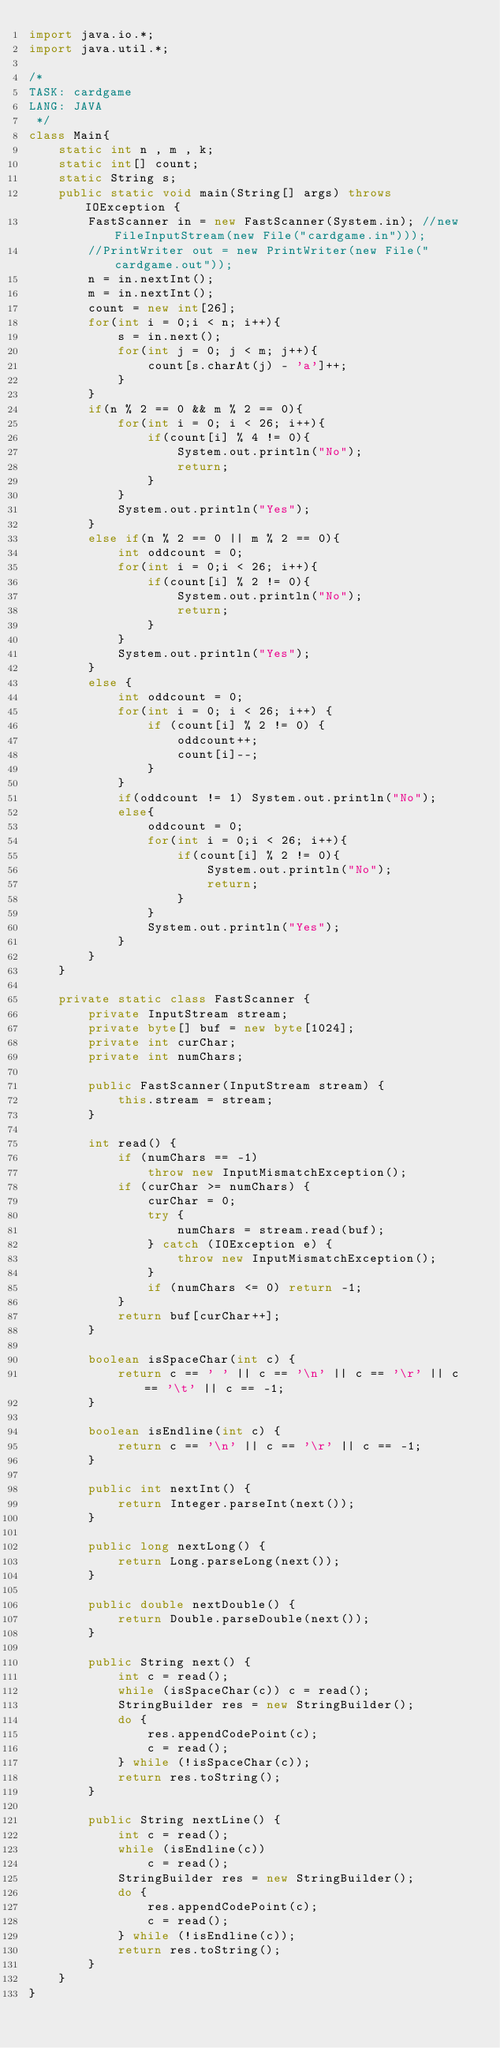Convert code to text. <code><loc_0><loc_0><loc_500><loc_500><_Java_>import java.io.*;
import java.util.*;

/*
TASK: cardgame
LANG: JAVA
 */
class Main{
    static int n , m , k;
    static int[] count;
    static String s;
    public static void main(String[] args) throws IOException {
        FastScanner in = new FastScanner(System.in); //new FileInputStream(new File("cardgame.in")));
        //PrintWriter out = new PrintWriter(new File("cardgame.out"));
        n = in.nextInt();
        m = in.nextInt();
        count = new int[26];
        for(int i = 0;i < n; i++){
            s = in.next();
            for(int j = 0; j < m; j++){
                count[s.charAt(j) - 'a']++;
            }
        }
        if(n % 2 == 0 && m % 2 == 0){
            for(int i = 0; i < 26; i++){
                if(count[i] % 4 != 0){
                    System.out.println("No");
                    return;
                }
            }
            System.out.println("Yes");
        }
        else if(n % 2 == 0 || m % 2 == 0){
            int oddcount = 0;
            for(int i = 0;i < 26; i++){
                if(count[i] % 2 != 0){
                    System.out.println("No");
                    return;
                }
            }
            System.out.println("Yes");
        }
        else {
            int oddcount = 0;
            for(int i = 0; i < 26; i++) {
                if (count[i] % 2 != 0) {
                    oddcount++;
                    count[i]--;
                }
            }
            if(oddcount != 1) System.out.println("No");
            else{
                oddcount = 0;
                for(int i = 0;i < 26; i++){
                    if(count[i] % 2 != 0){
                        System.out.println("No");
                        return;
                    }
                }
                System.out.println("Yes");
            }
        }
    }

    private static class FastScanner {
        private InputStream stream;
        private byte[] buf = new byte[1024];
        private int curChar;
        private int numChars;

        public FastScanner(InputStream stream) {
            this.stream = stream;
        }

        int read() {
            if (numChars == -1)
                throw new InputMismatchException();
            if (curChar >= numChars) {
                curChar = 0;
                try {
                    numChars = stream.read(buf);
                } catch (IOException e) {
                    throw new InputMismatchException();
                }
                if (numChars <= 0) return -1;
            }
            return buf[curChar++];
        }

        boolean isSpaceChar(int c) {
            return c == ' ' || c == '\n' || c == '\r' || c == '\t' || c == -1;
        }

        boolean isEndline(int c) {
            return c == '\n' || c == '\r' || c == -1;
        }

        public int nextInt() {
            return Integer.parseInt(next());
        }

        public long nextLong() {
            return Long.parseLong(next());
        }

        public double nextDouble() {
            return Double.parseDouble(next());
        }

        public String next() {
            int c = read();
            while (isSpaceChar(c)) c = read();
            StringBuilder res = new StringBuilder();
            do {
                res.appendCodePoint(c);
                c = read();
            } while (!isSpaceChar(c));
            return res.toString();
        }

        public String nextLine() {
            int c = read();
            while (isEndline(c))
                c = read();
            StringBuilder res = new StringBuilder();
            do {
                res.appendCodePoint(c);
                c = read();
            } while (!isEndline(c));
            return res.toString();
        }
    }
}
</code> 